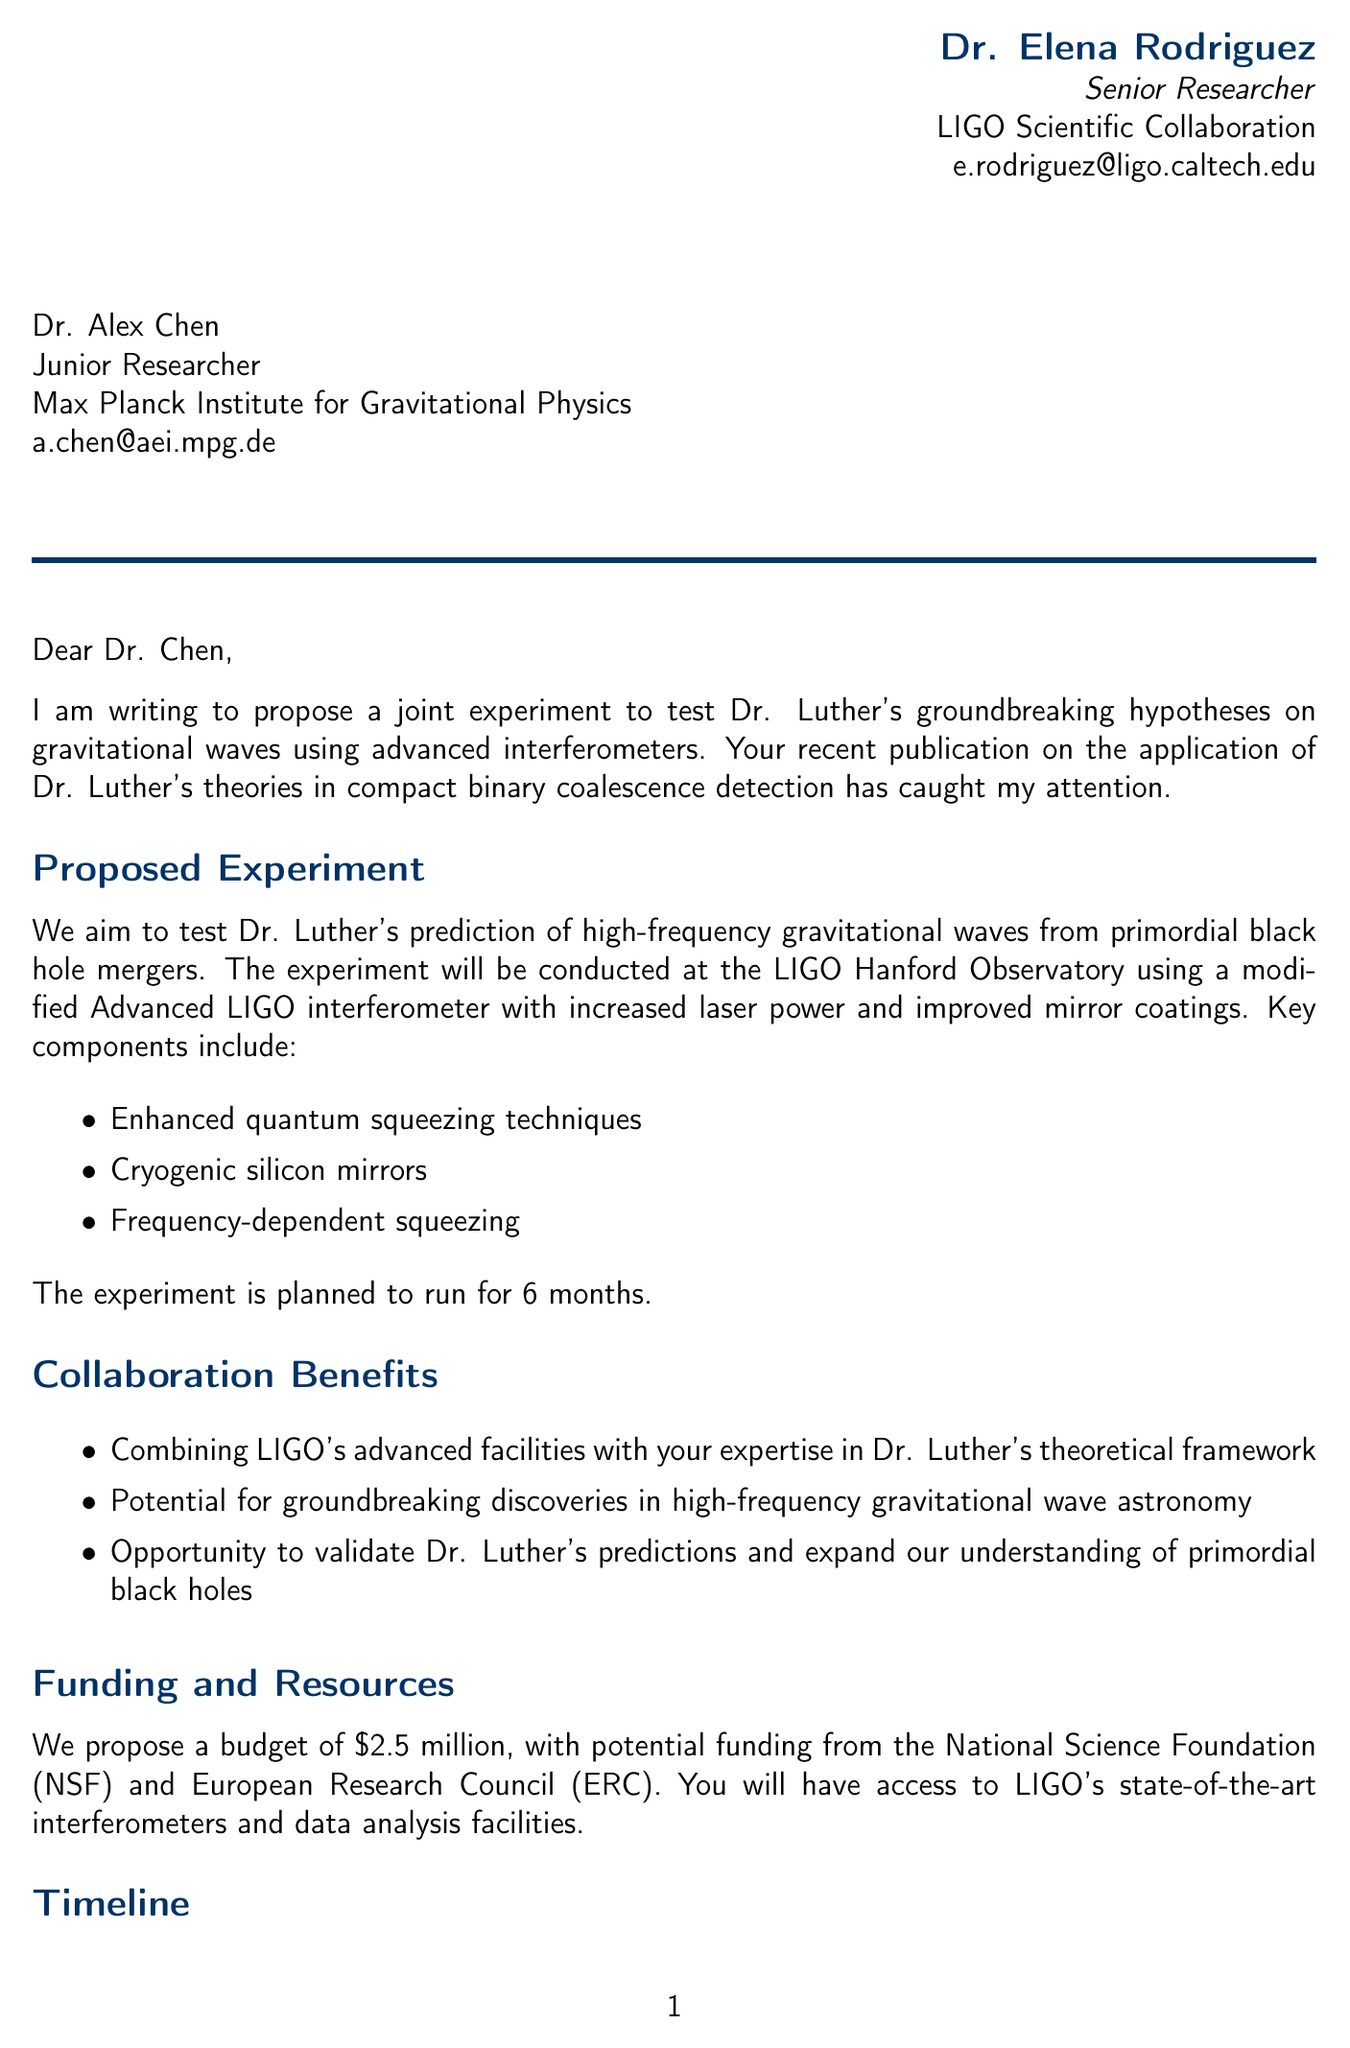What is the sender's name? The sender's name can be found at the beginning of the letter, listed in the sender's information.
Answer: Dr. Elena Rodriguez What is the proposed budget for the experiment? The proposed budget is clearly stated under the funding and resources section of the letter.
Answer: $2.5 million Where will the experiment be conducted? The location of the experiment is specified in the section detailing the experiment setup.
Answer: LIGO Hanford Observatory What hypothesis is being tested? The hypothesis is mentioned in the proposed experiment section, which can be identified by its description.
Answer: High-frequency gravitational waves from primordial black hole mergers What is the duration of the experiment? The duration is outlined in the details of the proposed experiment.
Answer: 6 months Which funding sources are mentioned? The funding sources are listed under the funding and resources section of the letter.
Answer: National Science Foundation (NSF), European Research Council (ERC) What are the key components of the proposed setup? The key components are listed in the proposed experiment section, providing specific details about the technology used.
Answer: Enhanced quantum squeezing techniques, Cryogenic silicon mirrors, Frequency-dependent squeezing What is the suggested next step if the recipient is interested? The suggested next step is indicated in the closing remarks of the letter.
Answer: Schedule a video conference What is the recipient's position? The recipient's position is stated in the address section of the letter.
Answer: Junior Researcher 